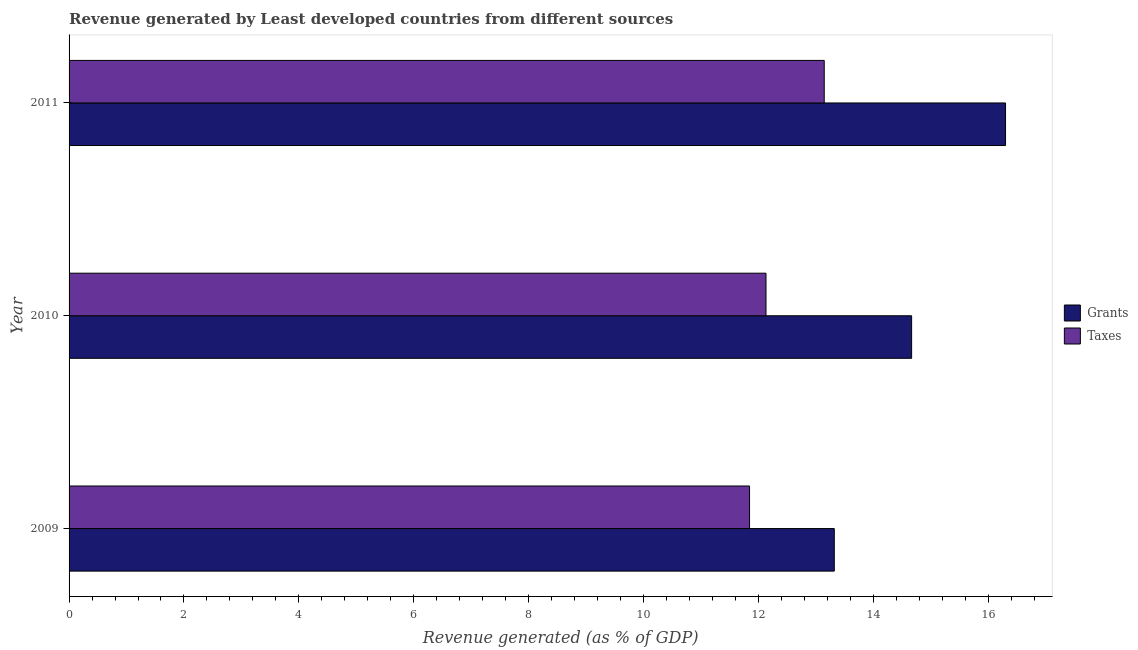How many different coloured bars are there?
Your response must be concise. 2. How many groups of bars are there?
Provide a succinct answer. 3. Are the number of bars per tick equal to the number of legend labels?
Your answer should be compact. Yes. What is the label of the 3rd group of bars from the top?
Ensure brevity in your answer.  2009. What is the revenue generated by taxes in 2010?
Give a very brief answer. 12.13. Across all years, what is the maximum revenue generated by grants?
Your answer should be compact. 16.3. Across all years, what is the minimum revenue generated by grants?
Give a very brief answer. 13.32. What is the total revenue generated by grants in the graph?
Your response must be concise. 44.3. What is the difference between the revenue generated by grants in 2009 and that in 2011?
Your response must be concise. -2.98. What is the difference between the revenue generated by grants in 2009 and the revenue generated by taxes in 2011?
Your answer should be compact. 0.18. What is the average revenue generated by taxes per year?
Offer a very short reply. 12.38. In the year 2009, what is the difference between the revenue generated by grants and revenue generated by taxes?
Provide a succinct answer. 1.48. In how many years, is the revenue generated by taxes greater than 16 %?
Provide a short and direct response. 0. What is the ratio of the revenue generated by grants in 2009 to that in 2010?
Your response must be concise. 0.91. Is the revenue generated by taxes in 2009 less than that in 2010?
Provide a short and direct response. Yes. Is the difference between the revenue generated by grants in 2009 and 2011 greater than the difference between the revenue generated by taxes in 2009 and 2011?
Your answer should be compact. No. What is the difference between the highest and the second highest revenue generated by grants?
Give a very brief answer. 1.64. What is the difference between the highest and the lowest revenue generated by grants?
Your answer should be compact. 2.98. In how many years, is the revenue generated by grants greater than the average revenue generated by grants taken over all years?
Your answer should be very brief. 1. What does the 2nd bar from the top in 2010 represents?
Provide a succinct answer. Grants. What does the 2nd bar from the bottom in 2010 represents?
Offer a terse response. Taxes. Are all the bars in the graph horizontal?
Make the answer very short. Yes. Are the values on the major ticks of X-axis written in scientific E-notation?
Provide a short and direct response. No. Does the graph contain any zero values?
Provide a succinct answer. No. Where does the legend appear in the graph?
Your answer should be very brief. Center right. How are the legend labels stacked?
Ensure brevity in your answer.  Vertical. What is the title of the graph?
Provide a short and direct response. Revenue generated by Least developed countries from different sources. What is the label or title of the X-axis?
Provide a succinct answer. Revenue generated (as % of GDP). What is the Revenue generated (as % of GDP) in Grants in 2009?
Your answer should be very brief. 13.32. What is the Revenue generated (as % of GDP) in Taxes in 2009?
Give a very brief answer. 11.85. What is the Revenue generated (as % of GDP) of Grants in 2010?
Your answer should be compact. 14.67. What is the Revenue generated (as % of GDP) of Taxes in 2010?
Offer a terse response. 12.13. What is the Revenue generated (as % of GDP) in Grants in 2011?
Your answer should be very brief. 16.3. What is the Revenue generated (as % of GDP) in Taxes in 2011?
Offer a terse response. 13.15. Across all years, what is the maximum Revenue generated (as % of GDP) of Grants?
Keep it short and to the point. 16.3. Across all years, what is the maximum Revenue generated (as % of GDP) in Taxes?
Give a very brief answer. 13.15. Across all years, what is the minimum Revenue generated (as % of GDP) of Grants?
Your answer should be very brief. 13.32. Across all years, what is the minimum Revenue generated (as % of GDP) of Taxes?
Give a very brief answer. 11.85. What is the total Revenue generated (as % of GDP) of Grants in the graph?
Give a very brief answer. 44.3. What is the total Revenue generated (as % of GDP) of Taxes in the graph?
Your answer should be very brief. 37.13. What is the difference between the Revenue generated (as % of GDP) in Grants in 2009 and that in 2010?
Give a very brief answer. -1.35. What is the difference between the Revenue generated (as % of GDP) in Taxes in 2009 and that in 2010?
Offer a terse response. -0.29. What is the difference between the Revenue generated (as % of GDP) of Grants in 2009 and that in 2011?
Your answer should be very brief. -2.98. What is the difference between the Revenue generated (as % of GDP) in Taxes in 2009 and that in 2011?
Give a very brief answer. -1.3. What is the difference between the Revenue generated (as % of GDP) in Grants in 2010 and that in 2011?
Provide a succinct answer. -1.64. What is the difference between the Revenue generated (as % of GDP) in Taxes in 2010 and that in 2011?
Ensure brevity in your answer.  -1.01. What is the difference between the Revenue generated (as % of GDP) in Grants in 2009 and the Revenue generated (as % of GDP) in Taxes in 2010?
Your answer should be very brief. 1.19. What is the difference between the Revenue generated (as % of GDP) in Grants in 2009 and the Revenue generated (as % of GDP) in Taxes in 2011?
Offer a terse response. 0.18. What is the difference between the Revenue generated (as % of GDP) of Grants in 2010 and the Revenue generated (as % of GDP) of Taxes in 2011?
Your answer should be compact. 1.52. What is the average Revenue generated (as % of GDP) in Grants per year?
Give a very brief answer. 14.77. What is the average Revenue generated (as % of GDP) of Taxes per year?
Ensure brevity in your answer.  12.38. In the year 2009, what is the difference between the Revenue generated (as % of GDP) in Grants and Revenue generated (as % of GDP) in Taxes?
Provide a short and direct response. 1.48. In the year 2010, what is the difference between the Revenue generated (as % of GDP) of Grants and Revenue generated (as % of GDP) of Taxes?
Make the answer very short. 2.54. In the year 2011, what is the difference between the Revenue generated (as % of GDP) of Grants and Revenue generated (as % of GDP) of Taxes?
Offer a terse response. 3.16. What is the ratio of the Revenue generated (as % of GDP) in Grants in 2009 to that in 2010?
Offer a very short reply. 0.91. What is the ratio of the Revenue generated (as % of GDP) of Taxes in 2009 to that in 2010?
Keep it short and to the point. 0.98. What is the ratio of the Revenue generated (as % of GDP) of Grants in 2009 to that in 2011?
Keep it short and to the point. 0.82. What is the ratio of the Revenue generated (as % of GDP) of Taxes in 2009 to that in 2011?
Your answer should be very brief. 0.9. What is the ratio of the Revenue generated (as % of GDP) of Grants in 2010 to that in 2011?
Provide a short and direct response. 0.9. What is the ratio of the Revenue generated (as % of GDP) of Taxes in 2010 to that in 2011?
Your answer should be compact. 0.92. What is the difference between the highest and the second highest Revenue generated (as % of GDP) in Grants?
Offer a very short reply. 1.64. What is the difference between the highest and the lowest Revenue generated (as % of GDP) in Grants?
Offer a terse response. 2.98. What is the difference between the highest and the lowest Revenue generated (as % of GDP) of Taxes?
Give a very brief answer. 1.3. 